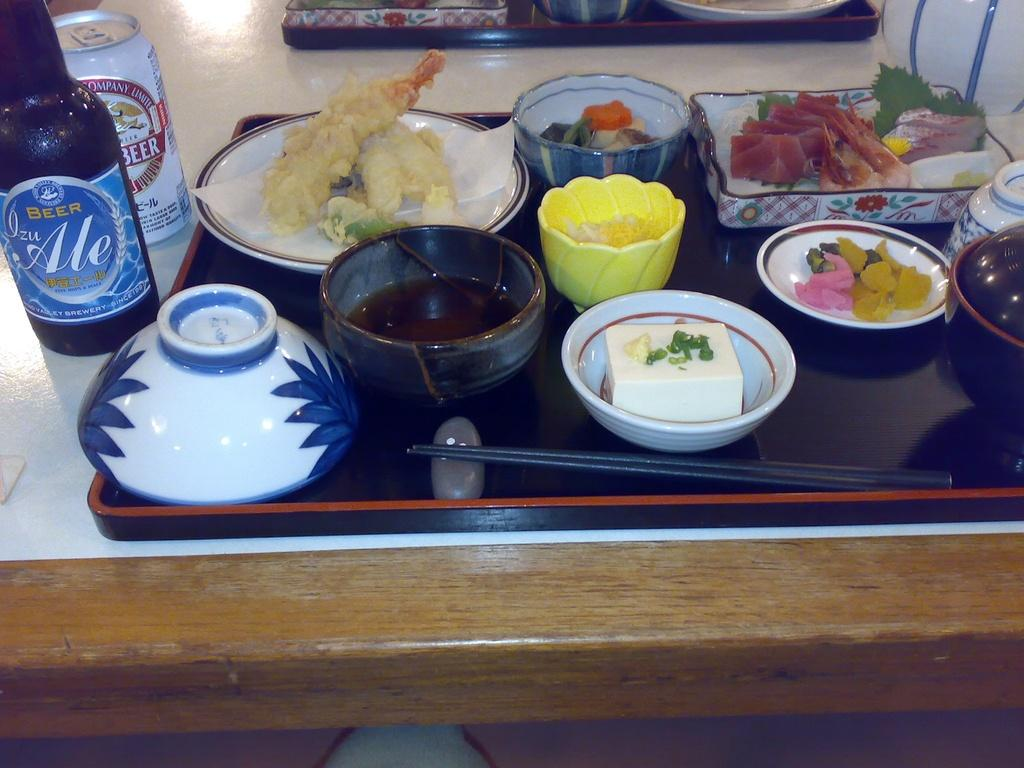What type of food items can be seen in the image? There are bowls with food items in the image. What utensils are visible in the image? Chopsticks are visible in the image. What is the purpose of the tray in the image? The tray is likely used for holding or serving the food items. What can be identified about the bottle in the image? There is a bottle with a label in the image. What other container is present in the image? There is a tin in the image. Where are all these objects located? All these objects are kept on a table. How many apples are comfortably sitting on the table in the image? There are no apples present in the image. What type of powder is visible in the image? There is no powder visible in the image. 